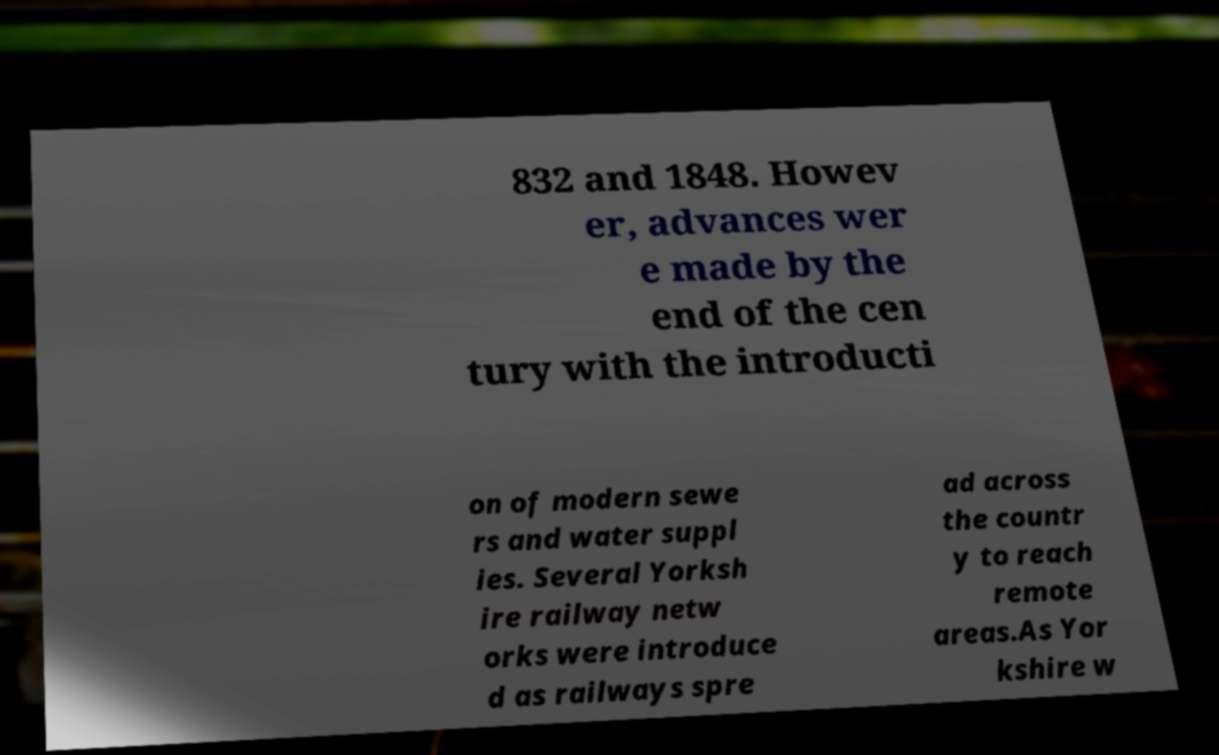For documentation purposes, I need the text within this image transcribed. Could you provide that? 832 and 1848. Howev er, advances wer e made by the end of the cen tury with the introducti on of modern sewe rs and water suppl ies. Several Yorksh ire railway netw orks were introduce d as railways spre ad across the countr y to reach remote areas.As Yor kshire w 